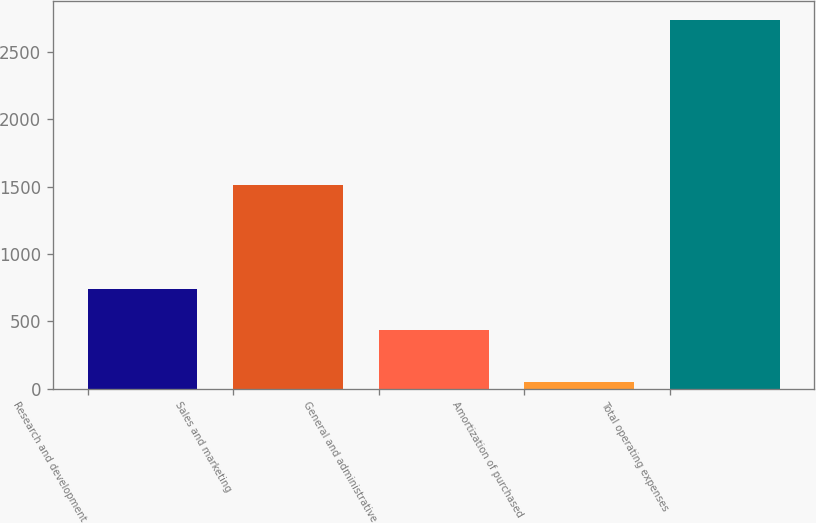<chart> <loc_0><loc_0><loc_500><loc_500><bar_chart><fcel>Research and development<fcel>Sales and marketing<fcel>General and administrative<fcel>Amortization of purchased<fcel>Total operating expenses<nl><fcel>742.8<fcel>1516.1<fcel>435<fcel>48.7<fcel>2739.7<nl></chart> 